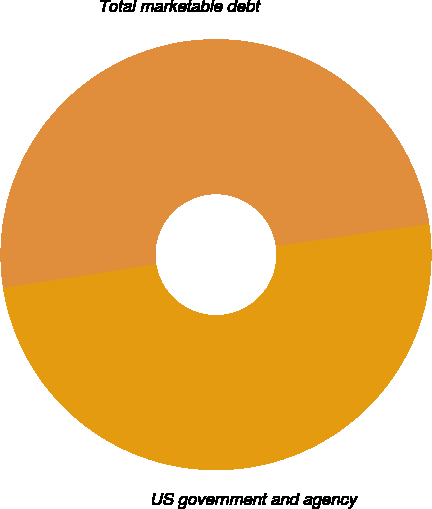Convert chart to OTSL. <chart><loc_0><loc_0><loc_500><loc_500><pie_chart><fcel>US government and agency<fcel>Total marketable debt<nl><fcel>49.83%<fcel>50.17%<nl></chart> 